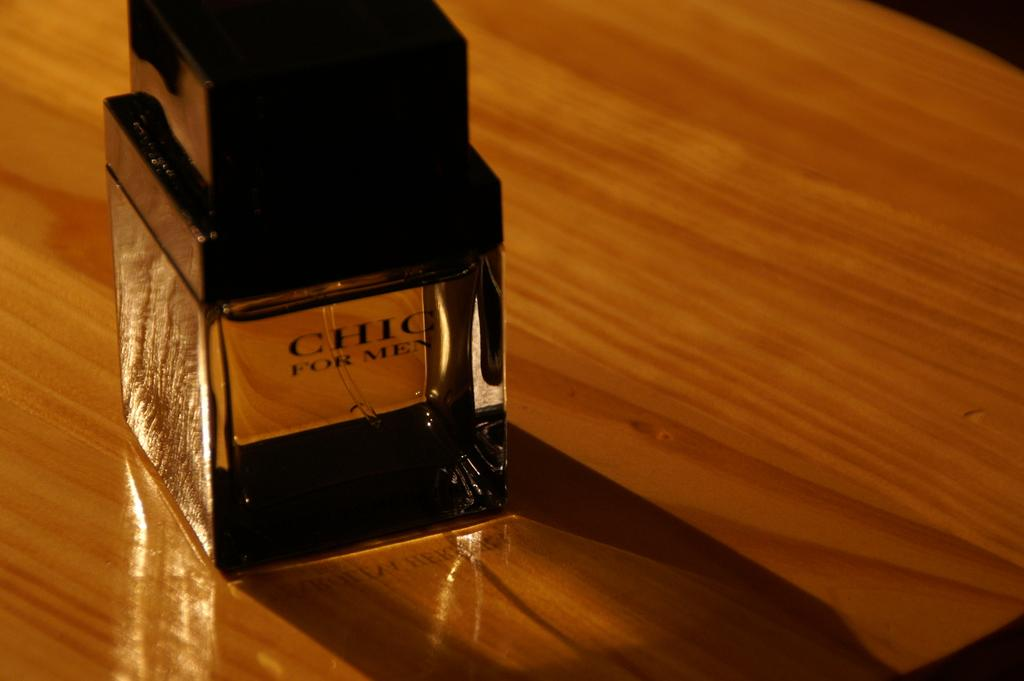Provide a one-sentence caption for the provided image. On a highly polished wooden table sits a bottle of Chic For Men. 